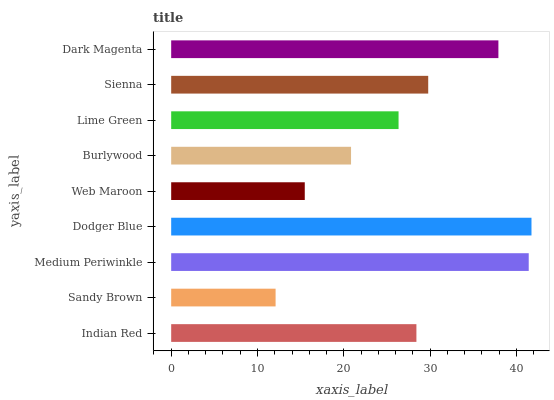Is Sandy Brown the minimum?
Answer yes or no. Yes. Is Dodger Blue the maximum?
Answer yes or no. Yes. Is Medium Periwinkle the minimum?
Answer yes or no. No. Is Medium Periwinkle the maximum?
Answer yes or no. No. Is Medium Periwinkle greater than Sandy Brown?
Answer yes or no. Yes. Is Sandy Brown less than Medium Periwinkle?
Answer yes or no. Yes. Is Sandy Brown greater than Medium Periwinkle?
Answer yes or no. No. Is Medium Periwinkle less than Sandy Brown?
Answer yes or no. No. Is Indian Red the high median?
Answer yes or no. Yes. Is Indian Red the low median?
Answer yes or no. Yes. Is Sienna the high median?
Answer yes or no. No. Is Medium Periwinkle the low median?
Answer yes or no. No. 